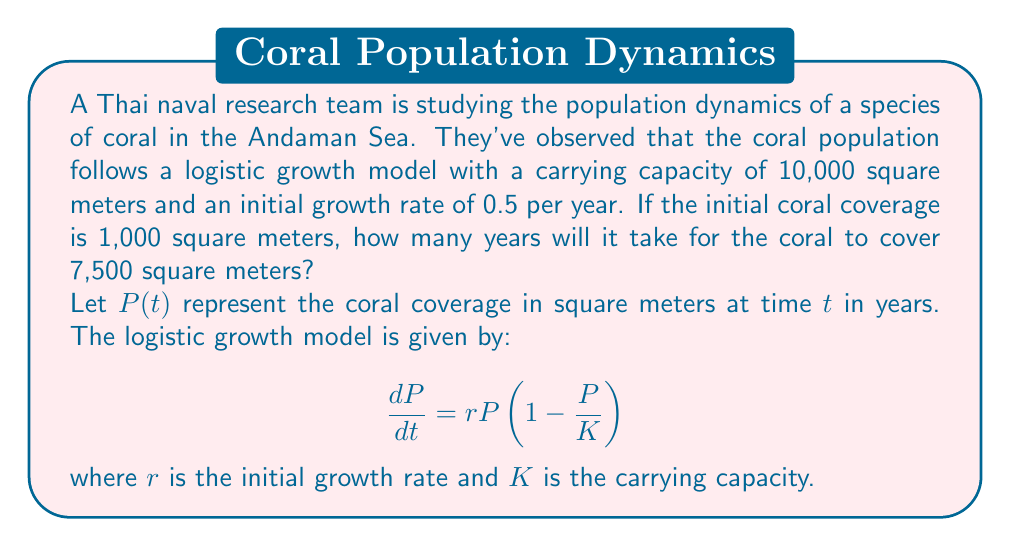Provide a solution to this math problem. To solve this problem, we'll use the logistic growth model's analytical solution:

$$P(t) = \frac{K}{1 + (\frac{K}{P_0} - 1)e^{-rt}}$$

Where:
$K = 10,000$ (carrying capacity)
$r = 0.5$ (initial growth rate)
$P_0 = 1,000$ (initial population)

We want to find $t$ when $P(t) = 7,500$.

1) Substitute the known values into the equation:

   $$7,500 = \frac{10,000}{1 + (\frac{10,000}{1,000} - 1)e^{-0.5t}}$$

2) Simplify:

   $$7,500 = \frac{10,000}{1 + 9e^{-0.5t}}$$

3) Multiply both sides by $(1 + 9e^{-0.5t})$:

   $$7,500(1 + 9e^{-0.5t}) = 10,000$$

4) Expand:

   $$7,500 + 67,500e^{-0.5t} = 10,000$$

5) Subtract 7,500 from both sides:

   $$67,500e^{-0.5t} = 2,500$$

6) Divide both sides by 67,500:

   $$e^{-0.5t} = \frac{1}{27}$$

7) Take the natural log of both sides:

   $$-0.5t = \ln(\frac{1}{27})$$

8) Divide both sides by -0.5:

   $$t = -\frac{2}{1}\ln(\frac{1}{27}) = 2\ln(27)$$

9) Calculate the final value:

   $$t \approx 6.58$$

Therefore, it will take approximately 6.58 years for the coral to cover 7,500 square meters.
Answer: $t \approx 6.58$ years 